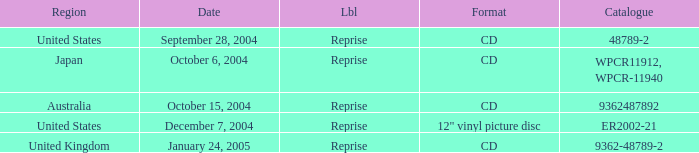Name the catalogue for australia 9362487892.0. 